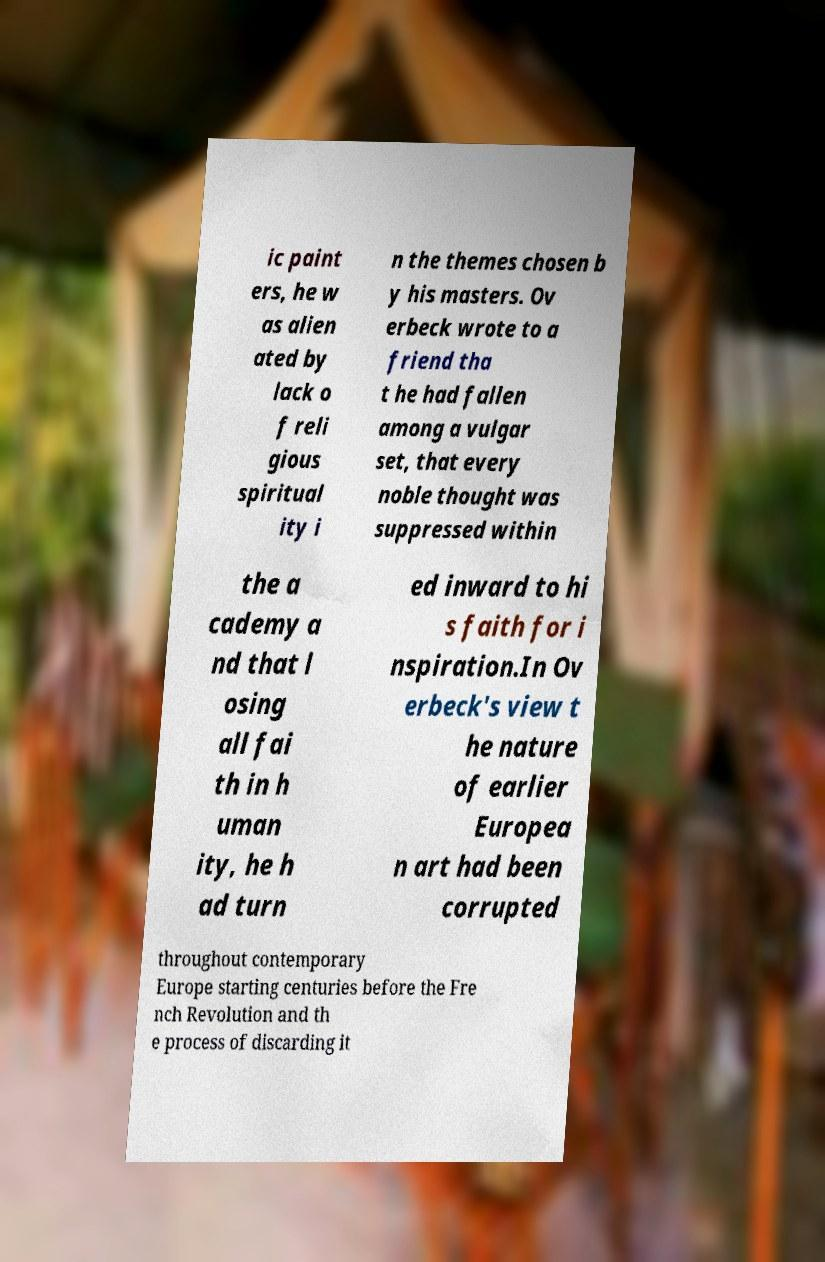Could you assist in decoding the text presented in this image and type it out clearly? ic paint ers, he w as alien ated by lack o f reli gious spiritual ity i n the themes chosen b y his masters. Ov erbeck wrote to a friend tha t he had fallen among a vulgar set, that every noble thought was suppressed within the a cademy a nd that l osing all fai th in h uman ity, he h ad turn ed inward to hi s faith for i nspiration.In Ov erbeck's view t he nature of earlier Europea n art had been corrupted throughout contemporary Europe starting centuries before the Fre nch Revolution and th e process of discarding it 